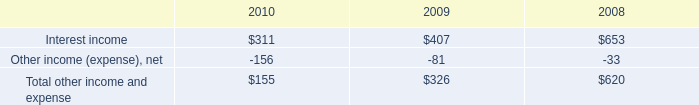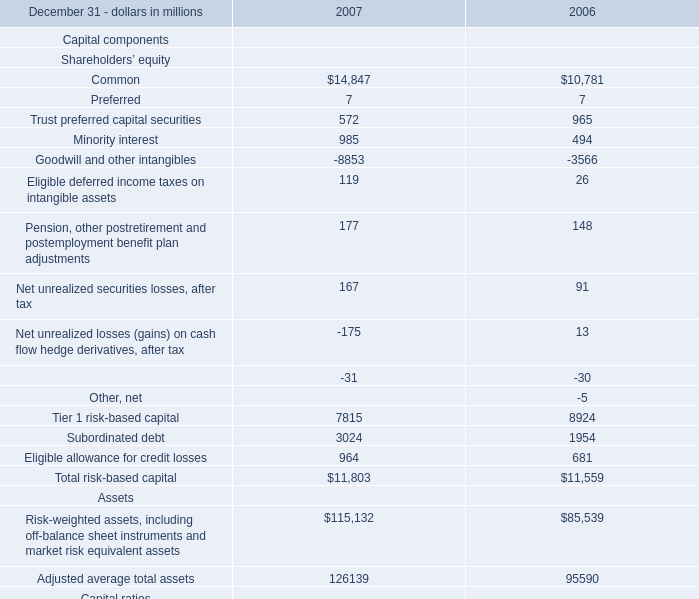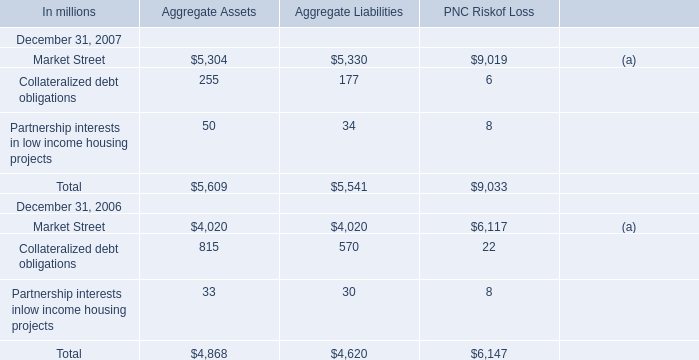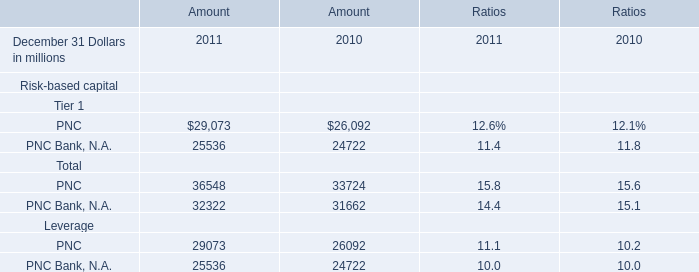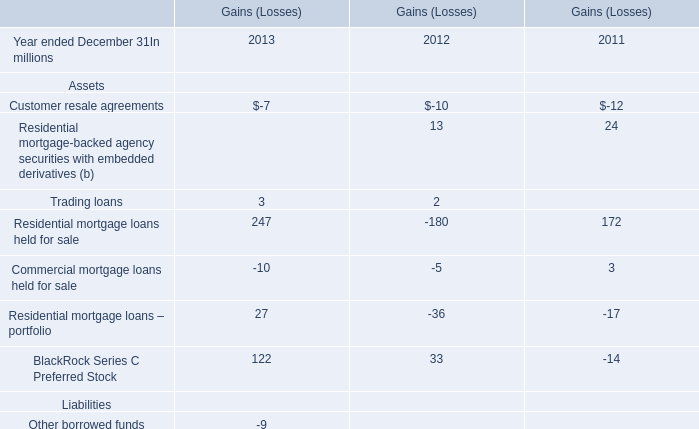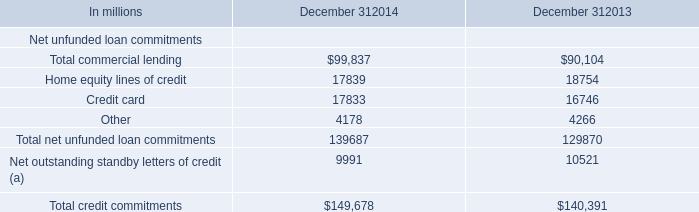What's the sum of all Aggregate Liabilities that are greater than 100 in 2007? (in million) 
Computations: (5330 + 177)
Answer: 5507.0. 